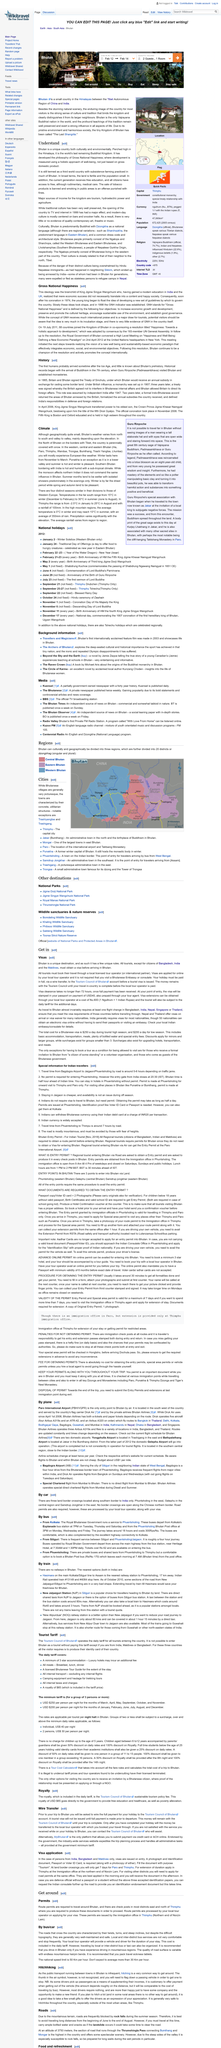Point out several critical features in this image. The sale of tobacco products is prohibited in Bhutan. Bhutan is located in the Himalaya, at a high elevation. Bhutan is the last remaining Buddhist kingdom in the world. 